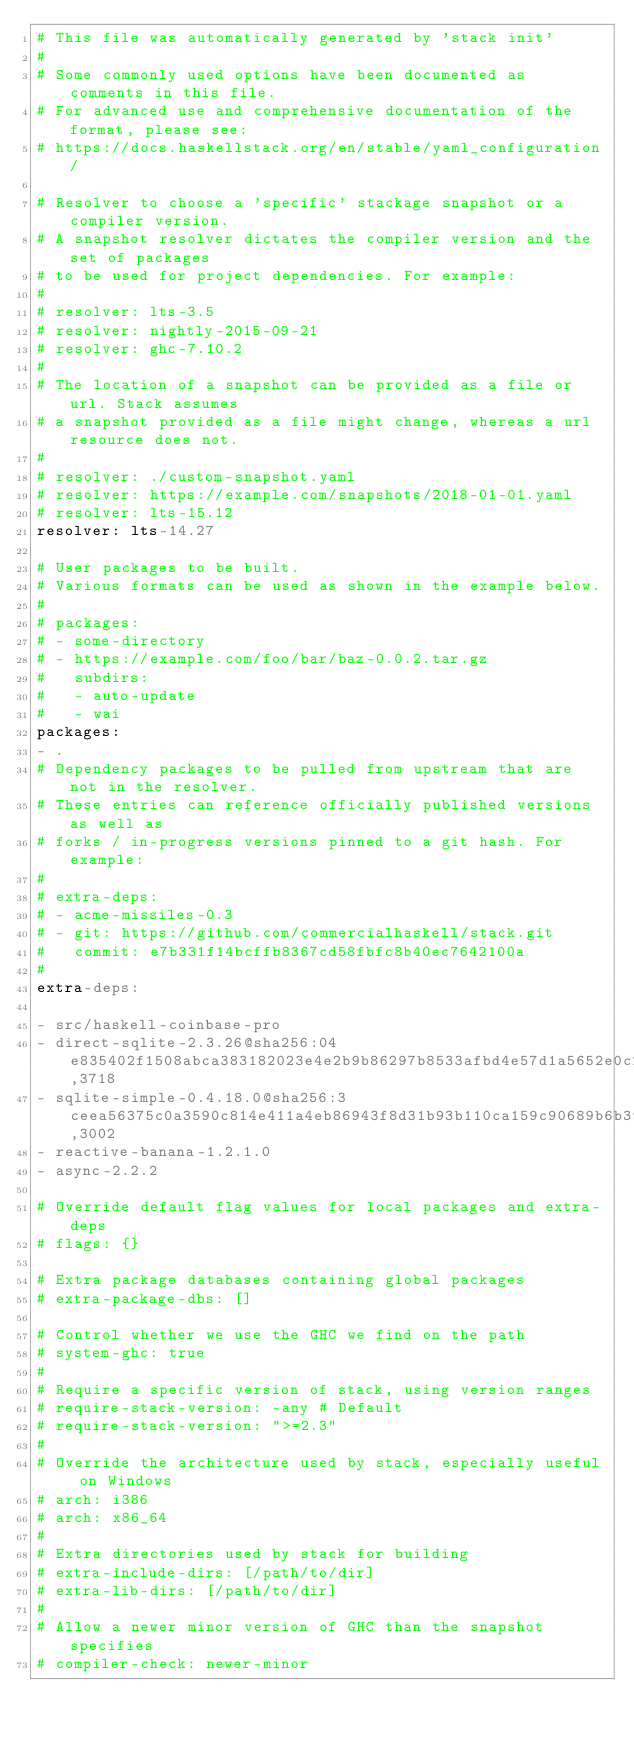<code> <loc_0><loc_0><loc_500><loc_500><_YAML_># This file was automatically generated by 'stack init'
#
# Some commonly used options have been documented as comments in this file.
# For advanced use and comprehensive documentation of the format, please see:
# https://docs.haskellstack.org/en/stable/yaml_configuration/

# Resolver to choose a 'specific' stackage snapshot or a compiler version.
# A snapshot resolver dictates the compiler version and the set of packages
# to be used for project dependencies. For example:
#
# resolver: lts-3.5
# resolver: nightly-2015-09-21
# resolver: ghc-7.10.2
#
# The location of a snapshot can be provided as a file or url. Stack assumes
# a snapshot provided as a file might change, whereas a url resource does not.
#
# resolver: ./custom-snapshot.yaml
# resolver: https://example.com/snapshots/2018-01-01.yaml
# resolver: lts-15.12
resolver: lts-14.27

# User packages to be built.
# Various formats can be used as shown in the example below.
#
# packages:
# - some-directory
# - https://example.com/foo/bar/baz-0.0.2.tar.gz
#   subdirs:
#   - auto-update
#   - wai
packages:
- .
# Dependency packages to be pulled from upstream that are not in the resolver.
# These entries can reference officially published versions as well as
# forks / in-progress versions pinned to a git hash. For example:
#
# extra-deps:
# - acme-missiles-0.3
# - git: https://github.com/commercialhaskell/stack.git
#   commit: e7b331f14bcffb8367cd58fbfc8b40ec7642100a
#
extra-deps:

- src/haskell-coinbase-pro
- direct-sqlite-2.3.26@sha256:04e835402f1508abca383182023e4e2b9b86297b8533afbd4e57d1a5652e0c23,3718
- sqlite-simple-0.4.18.0@sha256:3ceea56375c0a3590c814e411a4eb86943f8d31b93b110ca159c90689b6b39e5,3002
- reactive-banana-1.2.1.0
- async-2.2.2

# Override default flag values for local packages and extra-deps
# flags: {}

# Extra package databases containing global packages
# extra-package-dbs: []

# Control whether we use the GHC we find on the path
# system-ghc: true
#
# Require a specific version of stack, using version ranges
# require-stack-version: -any # Default
# require-stack-version: ">=2.3"
#
# Override the architecture used by stack, especially useful on Windows
# arch: i386
# arch: x86_64
#
# Extra directories used by stack for building
# extra-include-dirs: [/path/to/dir]
# extra-lib-dirs: [/path/to/dir]
#
# Allow a newer minor version of GHC than the snapshot specifies
# compiler-check: newer-minor
</code> 